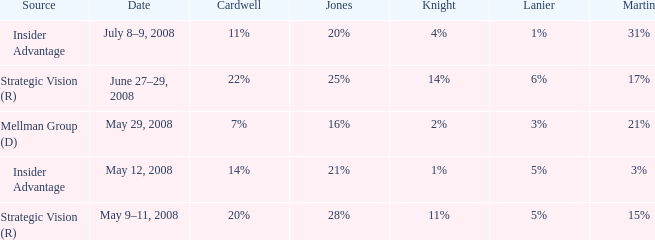What cardwell has an insider advantage and a knight of 1% 14%. 